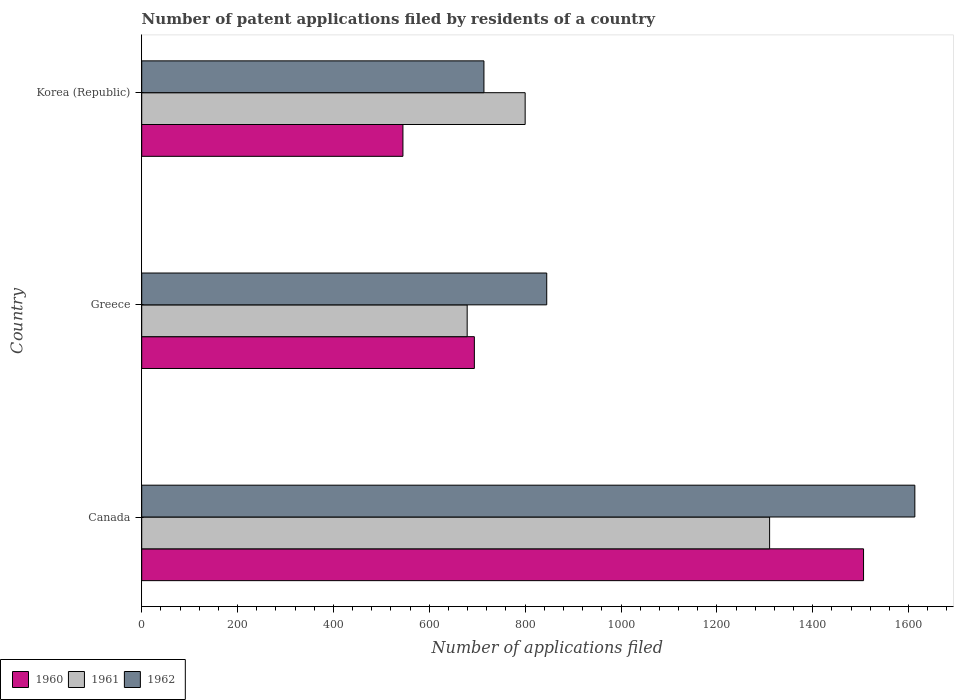How many groups of bars are there?
Your answer should be compact. 3. How many bars are there on the 3rd tick from the top?
Your answer should be very brief. 3. In how many cases, is the number of bars for a given country not equal to the number of legend labels?
Provide a short and direct response. 0. What is the number of applications filed in 1960 in Greece?
Offer a terse response. 694. Across all countries, what is the maximum number of applications filed in 1960?
Provide a short and direct response. 1506. Across all countries, what is the minimum number of applications filed in 1960?
Give a very brief answer. 545. In which country was the number of applications filed in 1961 minimum?
Keep it short and to the point. Greece. What is the total number of applications filed in 1960 in the graph?
Keep it short and to the point. 2745. What is the difference between the number of applications filed in 1960 in Canada and that in Korea (Republic)?
Keep it short and to the point. 961. What is the difference between the number of applications filed in 1962 in Greece and the number of applications filed in 1961 in Canada?
Provide a short and direct response. -465. What is the average number of applications filed in 1961 per country?
Provide a short and direct response. 929.67. What is the difference between the number of applications filed in 1962 and number of applications filed in 1961 in Greece?
Provide a short and direct response. 166. In how many countries, is the number of applications filed in 1961 greater than 880 ?
Provide a succinct answer. 1. What is the ratio of the number of applications filed in 1961 in Canada to that in Korea (Republic)?
Make the answer very short. 1.64. Is the difference between the number of applications filed in 1962 in Canada and Greece greater than the difference between the number of applications filed in 1961 in Canada and Greece?
Provide a succinct answer. Yes. What is the difference between the highest and the second highest number of applications filed in 1961?
Make the answer very short. 510. What is the difference between the highest and the lowest number of applications filed in 1962?
Make the answer very short. 899. What does the 2nd bar from the top in Korea (Republic) represents?
Your answer should be very brief. 1961. What does the 3rd bar from the bottom in Korea (Republic) represents?
Your answer should be compact. 1962. How many countries are there in the graph?
Your response must be concise. 3. What is the difference between two consecutive major ticks on the X-axis?
Provide a succinct answer. 200. Does the graph contain grids?
Offer a terse response. No. Where does the legend appear in the graph?
Your answer should be very brief. Bottom left. How many legend labels are there?
Your response must be concise. 3. How are the legend labels stacked?
Your answer should be compact. Horizontal. What is the title of the graph?
Provide a short and direct response. Number of patent applications filed by residents of a country. What is the label or title of the X-axis?
Ensure brevity in your answer.  Number of applications filed. What is the Number of applications filed of 1960 in Canada?
Keep it short and to the point. 1506. What is the Number of applications filed in 1961 in Canada?
Your answer should be compact. 1310. What is the Number of applications filed in 1962 in Canada?
Your response must be concise. 1613. What is the Number of applications filed of 1960 in Greece?
Your response must be concise. 694. What is the Number of applications filed of 1961 in Greece?
Make the answer very short. 679. What is the Number of applications filed of 1962 in Greece?
Give a very brief answer. 845. What is the Number of applications filed in 1960 in Korea (Republic)?
Make the answer very short. 545. What is the Number of applications filed of 1961 in Korea (Republic)?
Offer a terse response. 800. What is the Number of applications filed of 1962 in Korea (Republic)?
Provide a short and direct response. 714. Across all countries, what is the maximum Number of applications filed of 1960?
Make the answer very short. 1506. Across all countries, what is the maximum Number of applications filed of 1961?
Your answer should be compact. 1310. Across all countries, what is the maximum Number of applications filed of 1962?
Offer a very short reply. 1613. Across all countries, what is the minimum Number of applications filed of 1960?
Provide a short and direct response. 545. Across all countries, what is the minimum Number of applications filed in 1961?
Provide a succinct answer. 679. Across all countries, what is the minimum Number of applications filed of 1962?
Provide a succinct answer. 714. What is the total Number of applications filed in 1960 in the graph?
Offer a terse response. 2745. What is the total Number of applications filed of 1961 in the graph?
Offer a terse response. 2789. What is the total Number of applications filed in 1962 in the graph?
Your response must be concise. 3172. What is the difference between the Number of applications filed of 1960 in Canada and that in Greece?
Your answer should be compact. 812. What is the difference between the Number of applications filed of 1961 in Canada and that in Greece?
Ensure brevity in your answer.  631. What is the difference between the Number of applications filed of 1962 in Canada and that in Greece?
Provide a short and direct response. 768. What is the difference between the Number of applications filed in 1960 in Canada and that in Korea (Republic)?
Provide a succinct answer. 961. What is the difference between the Number of applications filed in 1961 in Canada and that in Korea (Republic)?
Keep it short and to the point. 510. What is the difference between the Number of applications filed in 1962 in Canada and that in Korea (Republic)?
Your answer should be very brief. 899. What is the difference between the Number of applications filed of 1960 in Greece and that in Korea (Republic)?
Provide a short and direct response. 149. What is the difference between the Number of applications filed of 1961 in Greece and that in Korea (Republic)?
Provide a succinct answer. -121. What is the difference between the Number of applications filed of 1962 in Greece and that in Korea (Republic)?
Ensure brevity in your answer.  131. What is the difference between the Number of applications filed of 1960 in Canada and the Number of applications filed of 1961 in Greece?
Give a very brief answer. 827. What is the difference between the Number of applications filed in 1960 in Canada and the Number of applications filed in 1962 in Greece?
Offer a terse response. 661. What is the difference between the Number of applications filed of 1961 in Canada and the Number of applications filed of 1962 in Greece?
Ensure brevity in your answer.  465. What is the difference between the Number of applications filed in 1960 in Canada and the Number of applications filed in 1961 in Korea (Republic)?
Your response must be concise. 706. What is the difference between the Number of applications filed in 1960 in Canada and the Number of applications filed in 1962 in Korea (Republic)?
Offer a terse response. 792. What is the difference between the Number of applications filed of 1961 in Canada and the Number of applications filed of 1962 in Korea (Republic)?
Your response must be concise. 596. What is the difference between the Number of applications filed of 1960 in Greece and the Number of applications filed of 1961 in Korea (Republic)?
Give a very brief answer. -106. What is the difference between the Number of applications filed of 1960 in Greece and the Number of applications filed of 1962 in Korea (Republic)?
Keep it short and to the point. -20. What is the difference between the Number of applications filed in 1961 in Greece and the Number of applications filed in 1962 in Korea (Republic)?
Make the answer very short. -35. What is the average Number of applications filed in 1960 per country?
Keep it short and to the point. 915. What is the average Number of applications filed of 1961 per country?
Your answer should be compact. 929.67. What is the average Number of applications filed of 1962 per country?
Your answer should be very brief. 1057.33. What is the difference between the Number of applications filed in 1960 and Number of applications filed in 1961 in Canada?
Ensure brevity in your answer.  196. What is the difference between the Number of applications filed of 1960 and Number of applications filed of 1962 in Canada?
Give a very brief answer. -107. What is the difference between the Number of applications filed in 1961 and Number of applications filed in 1962 in Canada?
Provide a succinct answer. -303. What is the difference between the Number of applications filed of 1960 and Number of applications filed of 1962 in Greece?
Your answer should be very brief. -151. What is the difference between the Number of applications filed in 1961 and Number of applications filed in 1962 in Greece?
Give a very brief answer. -166. What is the difference between the Number of applications filed in 1960 and Number of applications filed in 1961 in Korea (Republic)?
Make the answer very short. -255. What is the difference between the Number of applications filed in 1960 and Number of applications filed in 1962 in Korea (Republic)?
Keep it short and to the point. -169. What is the difference between the Number of applications filed of 1961 and Number of applications filed of 1962 in Korea (Republic)?
Provide a short and direct response. 86. What is the ratio of the Number of applications filed of 1960 in Canada to that in Greece?
Your answer should be compact. 2.17. What is the ratio of the Number of applications filed in 1961 in Canada to that in Greece?
Your response must be concise. 1.93. What is the ratio of the Number of applications filed of 1962 in Canada to that in Greece?
Your answer should be very brief. 1.91. What is the ratio of the Number of applications filed in 1960 in Canada to that in Korea (Republic)?
Keep it short and to the point. 2.76. What is the ratio of the Number of applications filed of 1961 in Canada to that in Korea (Republic)?
Ensure brevity in your answer.  1.64. What is the ratio of the Number of applications filed of 1962 in Canada to that in Korea (Republic)?
Your response must be concise. 2.26. What is the ratio of the Number of applications filed of 1960 in Greece to that in Korea (Republic)?
Your response must be concise. 1.27. What is the ratio of the Number of applications filed in 1961 in Greece to that in Korea (Republic)?
Offer a very short reply. 0.85. What is the ratio of the Number of applications filed of 1962 in Greece to that in Korea (Republic)?
Make the answer very short. 1.18. What is the difference between the highest and the second highest Number of applications filed in 1960?
Offer a very short reply. 812. What is the difference between the highest and the second highest Number of applications filed of 1961?
Keep it short and to the point. 510. What is the difference between the highest and the second highest Number of applications filed in 1962?
Make the answer very short. 768. What is the difference between the highest and the lowest Number of applications filed in 1960?
Provide a short and direct response. 961. What is the difference between the highest and the lowest Number of applications filed of 1961?
Your answer should be very brief. 631. What is the difference between the highest and the lowest Number of applications filed in 1962?
Offer a very short reply. 899. 